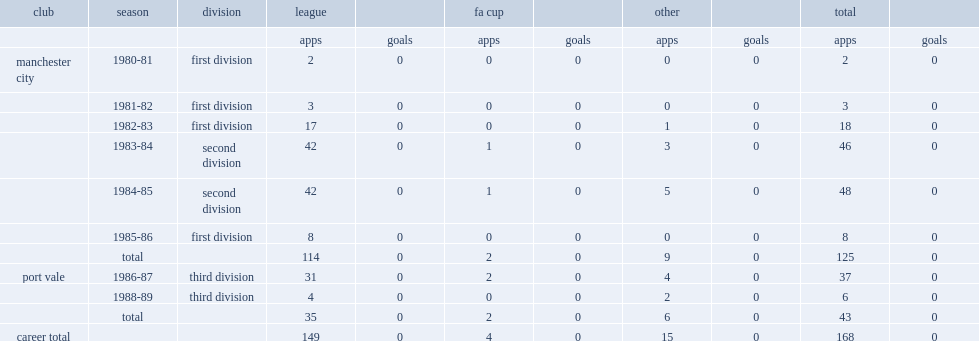How many league and cup appearances did alex williams make for manchester city between 1980 and 1986? 125.0. 